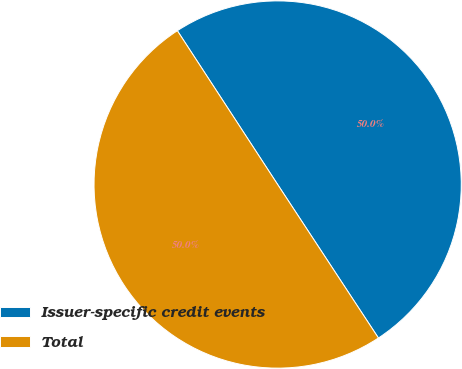Convert chart. <chart><loc_0><loc_0><loc_500><loc_500><pie_chart><fcel>Issuer-specific credit events<fcel>Total<nl><fcel>49.95%<fcel>50.05%<nl></chart> 